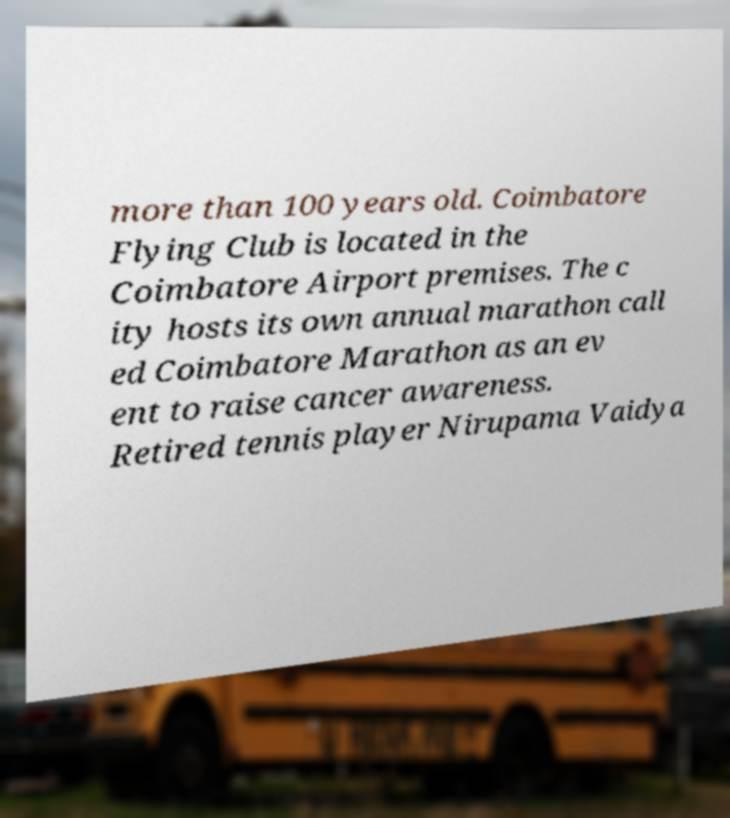I need the written content from this picture converted into text. Can you do that? more than 100 years old. Coimbatore Flying Club is located in the Coimbatore Airport premises. The c ity hosts its own annual marathon call ed Coimbatore Marathon as an ev ent to raise cancer awareness. Retired tennis player Nirupama Vaidya 